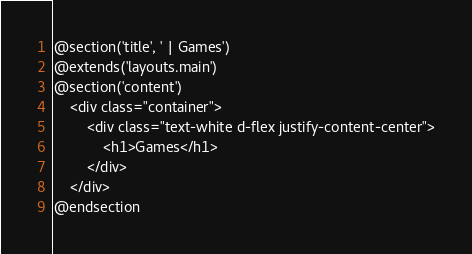<code> <loc_0><loc_0><loc_500><loc_500><_PHP_>@section('title', ' | Games')
@extends('layouts.main')
@section('content')
    <div class="container">
        <div class="text-white d-flex justify-content-center">
            <h1>Games</h1>
        </div>
    </div>
@endsection</code> 